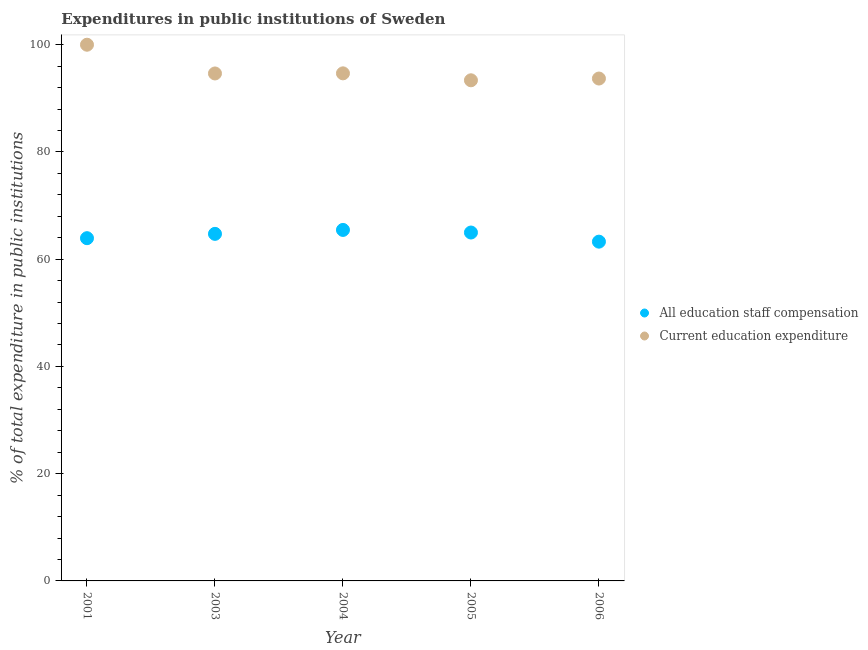How many different coloured dotlines are there?
Ensure brevity in your answer.  2. What is the expenditure in education in 2001?
Make the answer very short. 100. Across all years, what is the maximum expenditure in staff compensation?
Ensure brevity in your answer.  65.46. Across all years, what is the minimum expenditure in staff compensation?
Offer a terse response. 63.27. What is the total expenditure in staff compensation in the graph?
Ensure brevity in your answer.  322.35. What is the difference between the expenditure in staff compensation in 2001 and that in 2003?
Keep it short and to the point. -0.8. What is the difference between the expenditure in education in 2001 and the expenditure in staff compensation in 2004?
Your response must be concise. 34.54. What is the average expenditure in education per year?
Your response must be concise. 95.27. In the year 2005, what is the difference between the expenditure in staff compensation and expenditure in education?
Offer a very short reply. -28.39. What is the ratio of the expenditure in education in 2003 to that in 2004?
Keep it short and to the point. 1. Is the expenditure in staff compensation in 2005 less than that in 2006?
Your answer should be compact. No. Is the difference between the expenditure in staff compensation in 2005 and 2006 greater than the difference between the expenditure in education in 2005 and 2006?
Ensure brevity in your answer.  Yes. What is the difference between the highest and the second highest expenditure in staff compensation?
Offer a terse response. 0.48. What is the difference between the highest and the lowest expenditure in education?
Your answer should be compact. 6.63. In how many years, is the expenditure in staff compensation greater than the average expenditure in staff compensation taken over all years?
Your answer should be very brief. 3. Is the expenditure in education strictly greater than the expenditure in staff compensation over the years?
Your answer should be compact. Yes. How many dotlines are there?
Offer a terse response. 2. Are the values on the major ticks of Y-axis written in scientific E-notation?
Keep it short and to the point. No. Does the graph contain any zero values?
Ensure brevity in your answer.  No. Does the graph contain grids?
Provide a succinct answer. No. How are the legend labels stacked?
Provide a short and direct response. Vertical. What is the title of the graph?
Your answer should be very brief. Expenditures in public institutions of Sweden. What is the label or title of the Y-axis?
Your answer should be compact. % of total expenditure in public institutions. What is the % of total expenditure in public institutions in All education staff compensation in 2001?
Offer a very short reply. 63.92. What is the % of total expenditure in public institutions of Current education expenditure in 2001?
Offer a terse response. 100. What is the % of total expenditure in public institutions of All education staff compensation in 2003?
Offer a very short reply. 64.73. What is the % of total expenditure in public institutions of Current education expenditure in 2003?
Your response must be concise. 94.64. What is the % of total expenditure in public institutions of All education staff compensation in 2004?
Your answer should be compact. 65.46. What is the % of total expenditure in public institutions of Current education expenditure in 2004?
Your answer should be very brief. 94.66. What is the % of total expenditure in public institutions in All education staff compensation in 2005?
Your response must be concise. 64.98. What is the % of total expenditure in public institutions in Current education expenditure in 2005?
Offer a very short reply. 93.37. What is the % of total expenditure in public institutions in All education staff compensation in 2006?
Offer a terse response. 63.27. What is the % of total expenditure in public institutions in Current education expenditure in 2006?
Make the answer very short. 93.69. Across all years, what is the maximum % of total expenditure in public institutions in All education staff compensation?
Offer a very short reply. 65.46. Across all years, what is the minimum % of total expenditure in public institutions in All education staff compensation?
Offer a very short reply. 63.27. Across all years, what is the minimum % of total expenditure in public institutions in Current education expenditure?
Your answer should be very brief. 93.37. What is the total % of total expenditure in public institutions of All education staff compensation in the graph?
Make the answer very short. 322.35. What is the total % of total expenditure in public institutions of Current education expenditure in the graph?
Keep it short and to the point. 476.36. What is the difference between the % of total expenditure in public institutions in All education staff compensation in 2001 and that in 2003?
Make the answer very short. -0.8. What is the difference between the % of total expenditure in public institutions of Current education expenditure in 2001 and that in 2003?
Keep it short and to the point. 5.36. What is the difference between the % of total expenditure in public institutions in All education staff compensation in 2001 and that in 2004?
Your answer should be very brief. -1.54. What is the difference between the % of total expenditure in public institutions in Current education expenditure in 2001 and that in 2004?
Offer a very short reply. 5.34. What is the difference between the % of total expenditure in public institutions of All education staff compensation in 2001 and that in 2005?
Keep it short and to the point. -1.06. What is the difference between the % of total expenditure in public institutions in Current education expenditure in 2001 and that in 2005?
Ensure brevity in your answer.  6.63. What is the difference between the % of total expenditure in public institutions of All education staff compensation in 2001 and that in 2006?
Your answer should be compact. 0.65. What is the difference between the % of total expenditure in public institutions of Current education expenditure in 2001 and that in 2006?
Ensure brevity in your answer.  6.31. What is the difference between the % of total expenditure in public institutions in All education staff compensation in 2003 and that in 2004?
Ensure brevity in your answer.  -0.73. What is the difference between the % of total expenditure in public institutions in Current education expenditure in 2003 and that in 2004?
Your response must be concise. -0.02. What is the difference between the % of total expenditure in public institutions of All education staff compensation in 2003 and that in 2005?
Keep it short and to the point. -0.25. What is the difference between the % of total expenditure in public institutions of Current education expenditure in 2003 and that in 2005?
Keep it short and to the point. 1.27. What is the difference between the % of total expenditure in public institutions of All education staff compensation in 2003 and that in 2006?
Ensure brevity in your answer.  1.45. What is the difference between the % of total expenditure in public institutions of Current education expenditure in 2003 and that in 2006?
Your response must be concise. 0.95. What is the difference between the % of total expenditure in public institutions of All education staff compensation in 2004 and that in 2005?
Your answer should be very brief. 0.48. What is the difference between the % of total expenditure in public institutions in Current education expenditure in 2004 and that in 2005?
Provide a succinct answer. 1.3. What is the difference between the % of total expenditure in public institutions in All education staff compensation in 2004 and that in 2006?
Keep it short and to the point. 2.19. What is the difference between the % of total expenditure in public institutions in Current education expenditure in 2004 and that in 2006?
Provide a short and direct response. 0.97. What is the difference between the % of total expenditure in public institutions of All education staff compensation in 2005 and that in 2006?
Offer a very short reply. 1.7. What is the difference between the % of total expenditure in public institutions of Current education expenditure in 2005 and that in 2006?
Your response must be concise. -0.33. What is the difference between the % of total expenditure in public institutions of All education staff compensation in 2001 and the % of total expenditure in public institutions of Current education expenditure in 2003?
Provide a succinct answer. -30.72. What is the difference between the % of total expenditure in public institutions in All education staff compensation in 2001 and the % of total expenditure in public institutions in Current education expenditure in 2004?
Make the answer very short. -30.74. What is the difference between the % of total expenditure in public institutions of All education staff compensation in 2001 and the % of total expenditure in public institutions of Current education expenditure in 2005?
Provide a succinct answer. -29.45. What is the difference between the % of total expenditure in public institutions of All education staff compensation in 2001 and the % of total expenditure in public institutions of Current education expenditure in 2006?
Your answer should be compact. -29.77. What is the difference between the % of total expenditure in public institutions in All education staff compensation in 2003 and the % of total expenditure in public institutions in Current education expenditure in 2004?
Make the answer very short. -29.94. What is the difference between the % of total expenditure in public institutions of All education staff compensation in 2003 and the % of total expenditure in public institutions of Current education expenditure in 2005?
Give a very brief answer. -28.64. What is the difference between the % of total expenditure in public institutions in All education staff compensation in 2003 and the % of total expenditure in public institutions in Current education expenditure in 2006?
Provide a short and direct response. -28.97. What is the difference between the % of total expenditure in public institutions in All education staff compensation in 2004 and the % of total expenditure in public institutions in Current education expenditure in 2005?
Your answer should be compact. -27.91. What is the difference between the % of total expenditure in public institutions in All education staff compensation in 2004 and the % of total expenditure in public institutions in Current education expenditure in 2006?
Make the answer very short. -28.23. What is the difference between the % of total expenditure in public institutions of All education staff compensation in 2005 and the % of total expenditure in public institutions of Current education expenditure in 2006?
Make the answer very short. -28.72. What is the average % of total expenditure in public institutions of All education staff compensation per year?
Make the answer very short. 64.47. What is the average % of total expenditure in public institutions of Current education expenditure per year?
Ensure brevity in your answer.  95.27. In the year 2001, what is the difference between the % of total expenditure in public institutions of All education staff compensation and % of total expenditure in public institutions of Current education expenditure?
Offer a very short reply. -36.08. In the year 2003, what is the difference between the % of total expenditure in public institutions in All education staff compensation and % of total expenditure in public institutions in Current education expenditure?
Offer a terse response. -29.91. In the year 2004, what is the difference between the % of total expenditure in public institutions of All education staff compensation and % of total expenditure in public institutions of Current education expenditure?
Your response must be concise. -29.2. In the year 2005, what is the difference between the % of total expenditure in public institutions of All education staff compensation and % of total expenditure in public institutions of Current education expenditure?
Make the answer very short. -28.39. In the year 2006, what is the difference between the % of total expenditure in public institutions in All education staff compensation and % of total expenditure in public institutions in Current education expenditure?
Your answer should be very brief. -30.42. What is the ratio of the % of total expenditure in public institutions in All education staff compensation in 2001 to that in 2003?
Make the answer very short. 0.99. What is the ratio of the % of total expenditure in public institutions of Current education expenditure in 2001 to that in 2003?
Your answer should be very brief. 1.06. What is the ratio of the % of total expenditure in public institutions of All education staff compensation in 2001 to that in 2004?
Ensure brevity in your answer.  0.98. What is the ratio of the % of total expenditure in public institutions in Current education expenditure in 2001 to that in 2004?
Offer a very short reply. 1.06. What is the ratio of the % of total expenditure in public institutions in All education staff compensation in 2001 to that in 2005?
Provide a succinct answer. 0.98. What is the ratio of the % of total expenditure in public institutions in Current education expenditure in 2001 to that in 2005?
Offer a terse response. 1.07. What is the ratio of the % of total expenditure in public institutions in All education staff compensation in 2001 to that in 2006?
Offer a terse response. 1.01. What is the ratio of the % of total expenditure in public institutions in Current education expenditure in 2001 to that in 2006?
Provide a succinct answer. 1.07. What is the ratio of the % of total expenditure in public institutions of All education staff compensation in 2003 to that in 2004?
Your answer should be very brief. 0.99. What is the ratio of the % of total expenditure in public institutions of Current education expenditure in 2003 to that in 2004?
Make the answer very short. 1. What is the ratio of the % of total expenditure in public institutions of All education staff compensation in 2003 to that in 2005?
Give a very brief answer. 1. What is the ratio of the % of total expenditure in public institutions in Current education expenditure in 2003 to that in 2005?
Provide a short and direct response. 1.01. What is the ratio of the % of total expenditure in public institutions of All education staff compensation in 2003 to that in 2006?
Offer a very short reply. 1.02. What is the ratio of the % of total expenditure in public institutions of All education staff compensation in 2004 to that in 2005?
Give a very brief answer. 1.01. What is the ratio of the % of total expenditure in public institutions in Current education expenditure in 2004 to that in 2005?
Ensure brevity in your answer.  1.01. What is the ratio of the % of total expenditure in public institutions in All education staff compensation in 2004 to that in 2006?
Provide a short and direct response. 1.03. What is the ratio of the % of total expenditure in public institutions in Current education expenditure in 2004 to that in 2006?
Ensure brevity in your answer.  1.01. What is the ratio of the % of total expenditure in public institutions of All education staff compensation in 2005 to that in 2006?
Provide a succinct answer. 1.03. What is the difference between the highest and the second highest % of total expenditure in public institutions of All education staff compensation?
Keep it short and to the point. 0.48. What is the difference between the highest and the second highest % of total expenditure in public institutions in Current education expenditure?
Keep it short and to the point. 5.34. What is the difference between the highest and the lowest % of total expenditure in public institutions in All education staff compensation?
Offer a very short reply. 2.19. What is the difference between the highest and the lowest % of total expenditure in public institutions of Current education expenditure?
Your answer should be compact. 6.63. 